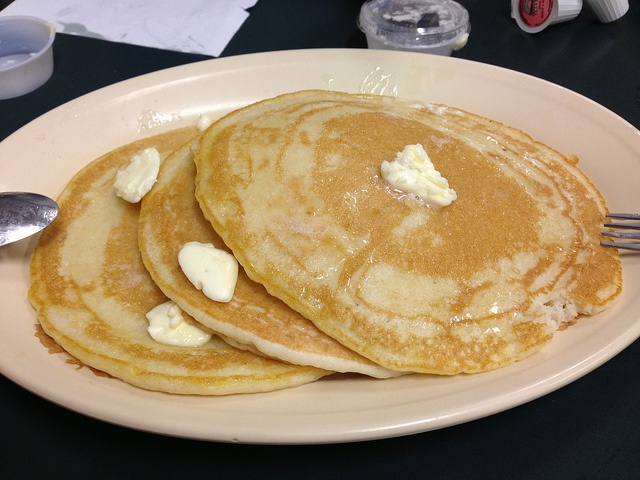Describe the objects in this image and their specific colors. I can see dining table in black, tan, and lightgray tones, spoon in black, gray, white, and darkgray tones, and fork in black and gray tones in this image. 